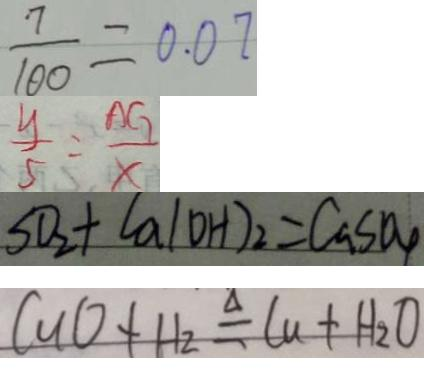<formula> <loc_0><loc_0><loc_500><loc_500>\frac { 7 } { 1 0 0 } = 0 . 0 7 
 \frac { y } { 5 } = \frac { A G } { x } 
 S O _ { 2 } + C a ( O H ) _ { 2 } = C a S O _ { 4 } 
 C u O + H _ { 2 } O \Delta q C u + H _ { 2 } O</formula> 